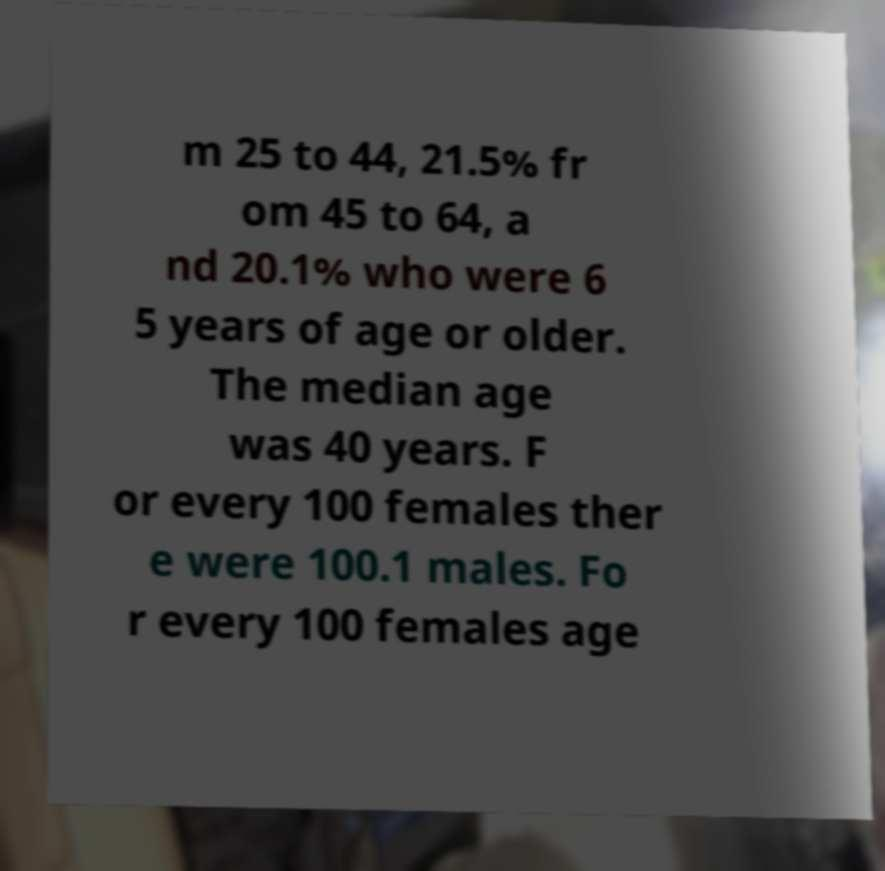Please read and relay the text visible in this image. What does it say? m 25 to 44, 21.5% fr om 45 to 64, a nd 20.1% who were 6 5 years of age or older. The median age was 40 years. F or every 100 females ther e were 100.1 males. Fo r every 100 females age 